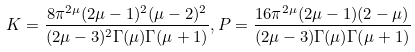<formula> <loc_0><loc_0><loc_500><loc_500>K = \frac { 8 \pi ^ { 2 \mu } ( 2 \mu - 1 ) ^ { 2 } ( \mu - 2 ) ^ { 2 } } { ( 2 \mu - 3 ) ^ { 2 } \Gamma ( \mu ) \Gamma ( \mu + 1 ) } , P = \frac { 1 6 \pi ^ { 2 \mu } ( 2 \mu - 1 ) ( 2 - \mu ) } { ( 2 \mu - 3 ) \Gamma ( \mu ) \Gamma ( \mu + 1 ) }</formula> 